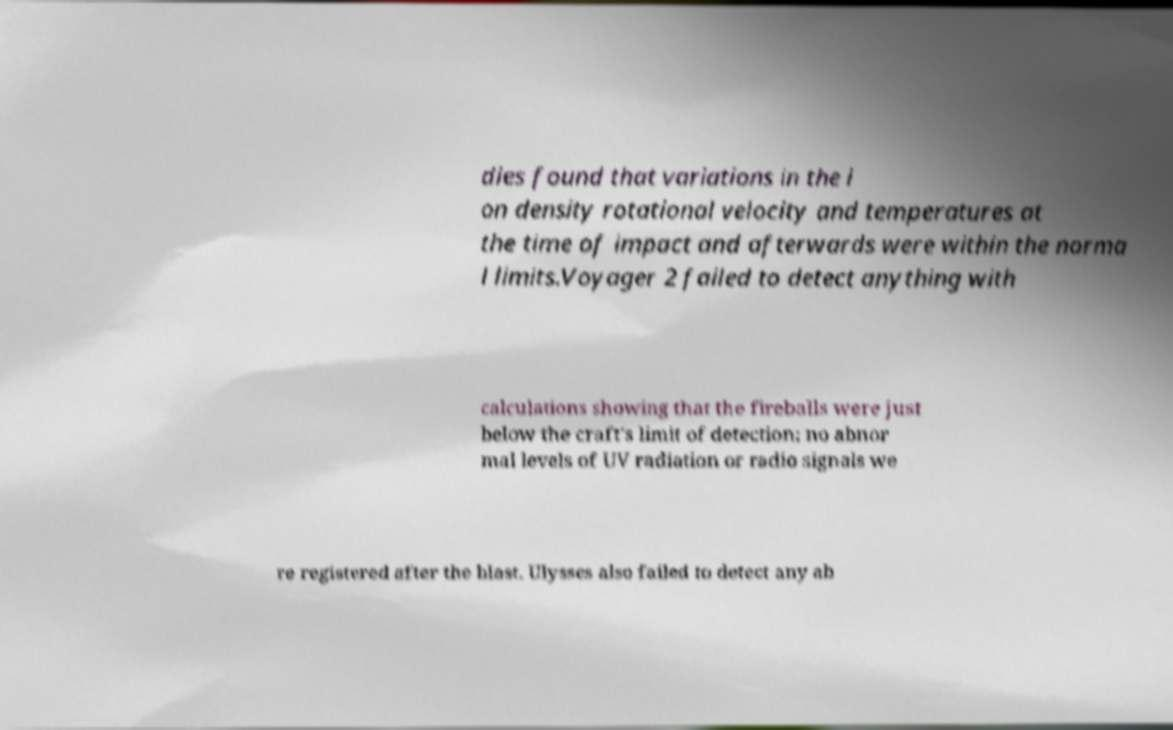Can you read and provide the text displayed in the image?This photo seems to have some interesting text. Can you extract and type it out for me? dies found that variations in the i on density rotational velocity and temperatures at the time of impact and afterwards were within the norma l limits.Voyager 2 failed to detect anything with calculations showing that the fireballs were just below the craft's limit of detection; no abnor mal levels of UV radiation or radio signals we re registered after the blast. Ulysses also failed to detect any ab 